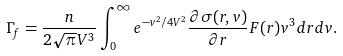Convert formula to latex. <formula><loc_0><loc_0><loc_500><loc_500>\Gamma _ { f } = \frac { n } { 2 \sqrt { \pi } V ^ { 3 } } \int ^ { \infty } _ { 0 } e ^ { - v ^ { 2 } / 4 V ^ { 2 } } \frac { \partial \sigma ( r , v ) } { \partial r } F ( r ) v ^ { 3 } d r d v .</formula> 